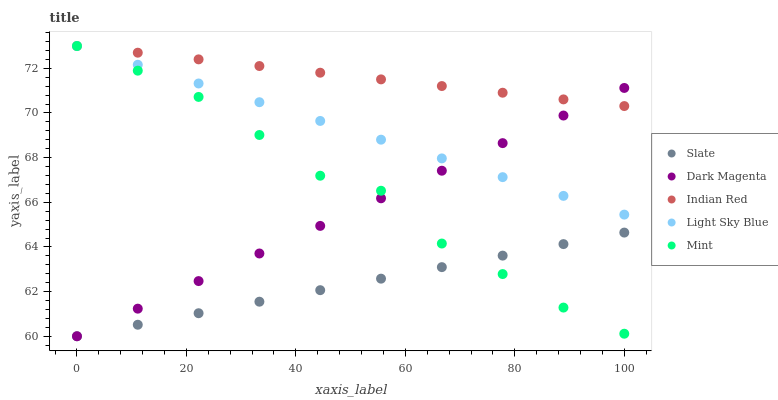Does Slate have the minimum area under the curve?
Answer yes or no. Yes. Does Indian Red have the maximum area under the curve?
Answer yes or no. Yes. Does Light Sky Blue have the minimum area under the curve?
Answer yes or no. No. Does Light Sky Blue have the maximum area under the curve?
Answer yes or no. No. Is Light Sky Blue the smoothest?
Answer yes or no. Yes. Is Mint the roughest?
Answer yes or no. Yes. Is Mint the smoothest?
Answer yes or no. No. Is Light Sky Blue the roughest?
Answer yes or no. No. Does Slate have the lowest value?
Answer yes or no. Yes. Does Light Sky Blue have the lowest value?
Answer yes or no. No. Does Indian Red have the highest value?
Answer yes or no. Yes. Does Dark Magenta have the highest value?
Answer yes or no. No. Is Slate less than Indian Red?
Answer yes or no. Yes. Is Light Sky Blue greater than Slate?
Answer yes or no. Yes. Does Slate intersect Dark Magenta?
Answer yes or no. Yes. Is Slate less than Dark Magenta?
Answer yes or no. No. Is Slate greater than Dark Magenta?
Answer yes or no. No. Does Slate intersect Indian Red?
Answer yes or no. No. 